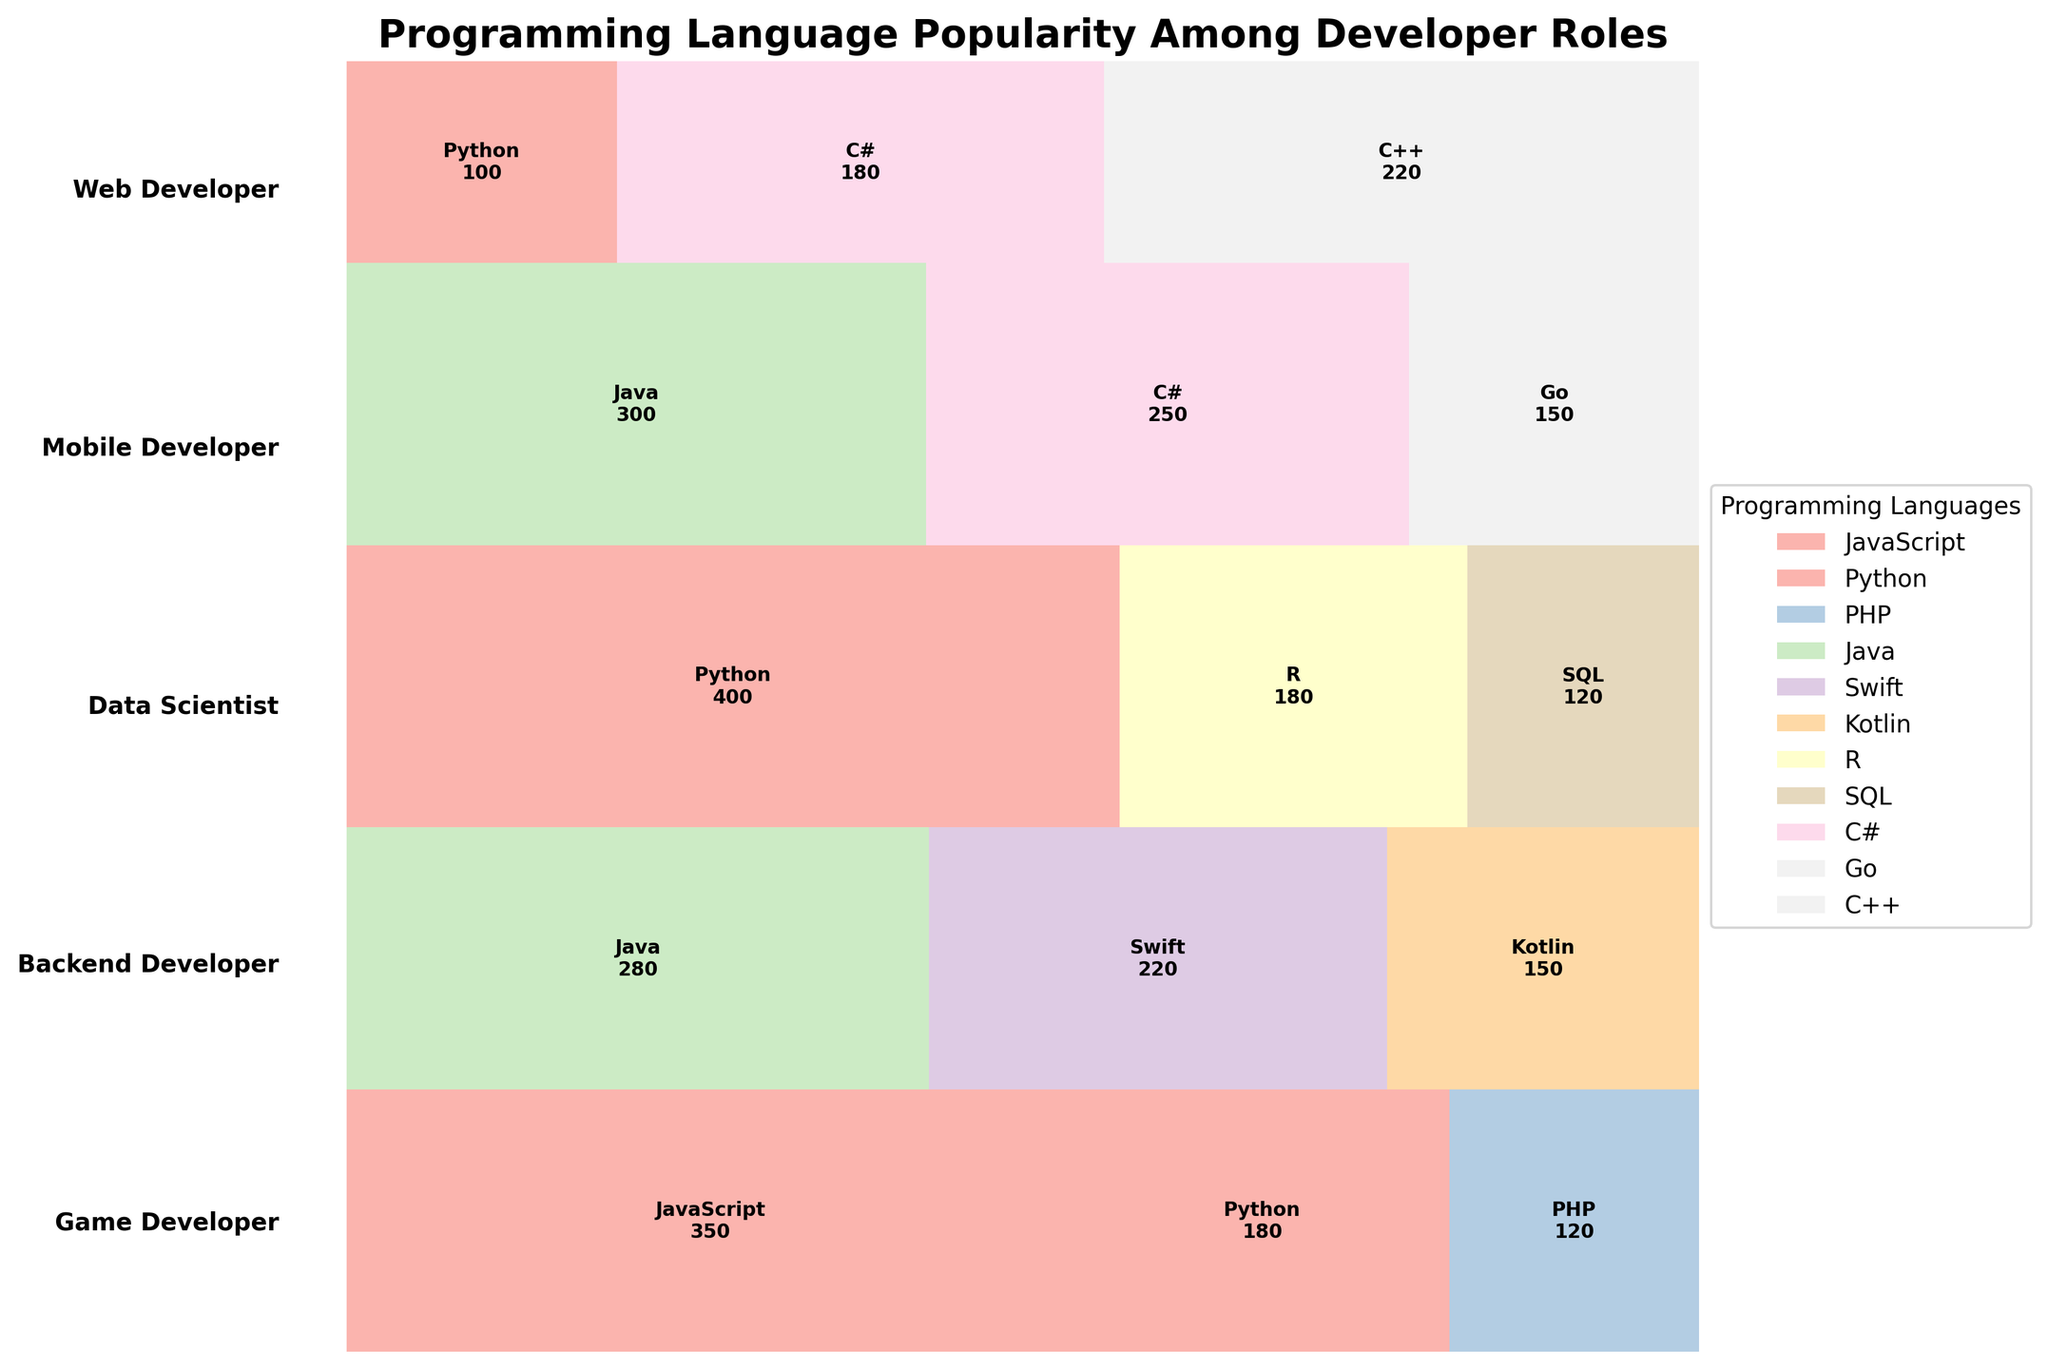what is the title of the figure? The title of the figure is found at the top of the plot. It summarizes the content, indicating what the visual is about. In this case, the title states: "Programming Language Popularity Among Developer Roles."
Answer: Programming Language Popularity Among Developer Roles Which programming language has the highest count among web developers? To find this, look at the segment labeled 'Web Developer' and identify the language with the largest portion. JavaScript occupies the largest section with a count of 350.
Answer: JavaScript What is the combined total count of Python across all developer roles? First, locate all segments labeled 'Python' within the plot. Sum the counts provided in each segment: Web Developer (180), Data Scientist (400), and Game Developer (100). Thus, 180 + 400 + 100 = 680.
Answer: 680 Which developer role uses the most diverse set of programming languages? The diversity is indicated by the number of different languages a role is shown to use. Compare the different segments for each role: Web Developer (3), Mobile Developer (3), Data Scientist (3), Backend Developer (3), and Game Developer (3). All roles display equal diversity.
Answer: All roles have equal diversity Compare the popularity of Python and Java among developer roles. Which language is used more overall? Sum the counts of each role for Python and Java. For Python: 180 (Web Developer) + 400 (Data Scientist) + 100 (Game Developer) = 680. For Java: 280 (Mobile Developer) + 300 (Backend Developer) = 580. Python has a higher overall count.
Answer: Python In which developer role does C++ appear, and how many developers use it? Locate the segment labeled 'Game Developer' and find the area designated for C++. The count is provided within the section, showing that 220 developers use C++.
Answer: Game Developer, 220 What is the total count of developers in the 'Mobile Developer' role? Add up the counts for each programming language within the 'Mobile Developer' role: 280 (Java) + 220 (Swift) + 150 (Kotlin) = 650.
Answer: 650 Between Backend Developers and Game Developers, which role has more developers using C#? Compare the counts of C# between these roles: Backend Developer (250) and Game Developer (180). Backend Developers have more C# users.
Answer: Backend Developers How does the popularity of SQL compare between Data Scientists and other developer roles? SQL appears only within the Data Scientist role segment with a count of 120. No other roles show SQL usage in this plot. Thus, only Data Scientists use SQL.
Answer: Data Scientists Which developer role has the least number of different programming languages used, and how many languages do they use? All roles shown (Web Developer, Mobile Developer, Data Scientist, Backend Developer, Game Developer) use three different programming languages. Therefore, no role uses fewer.
Answer: All roles use three languages 